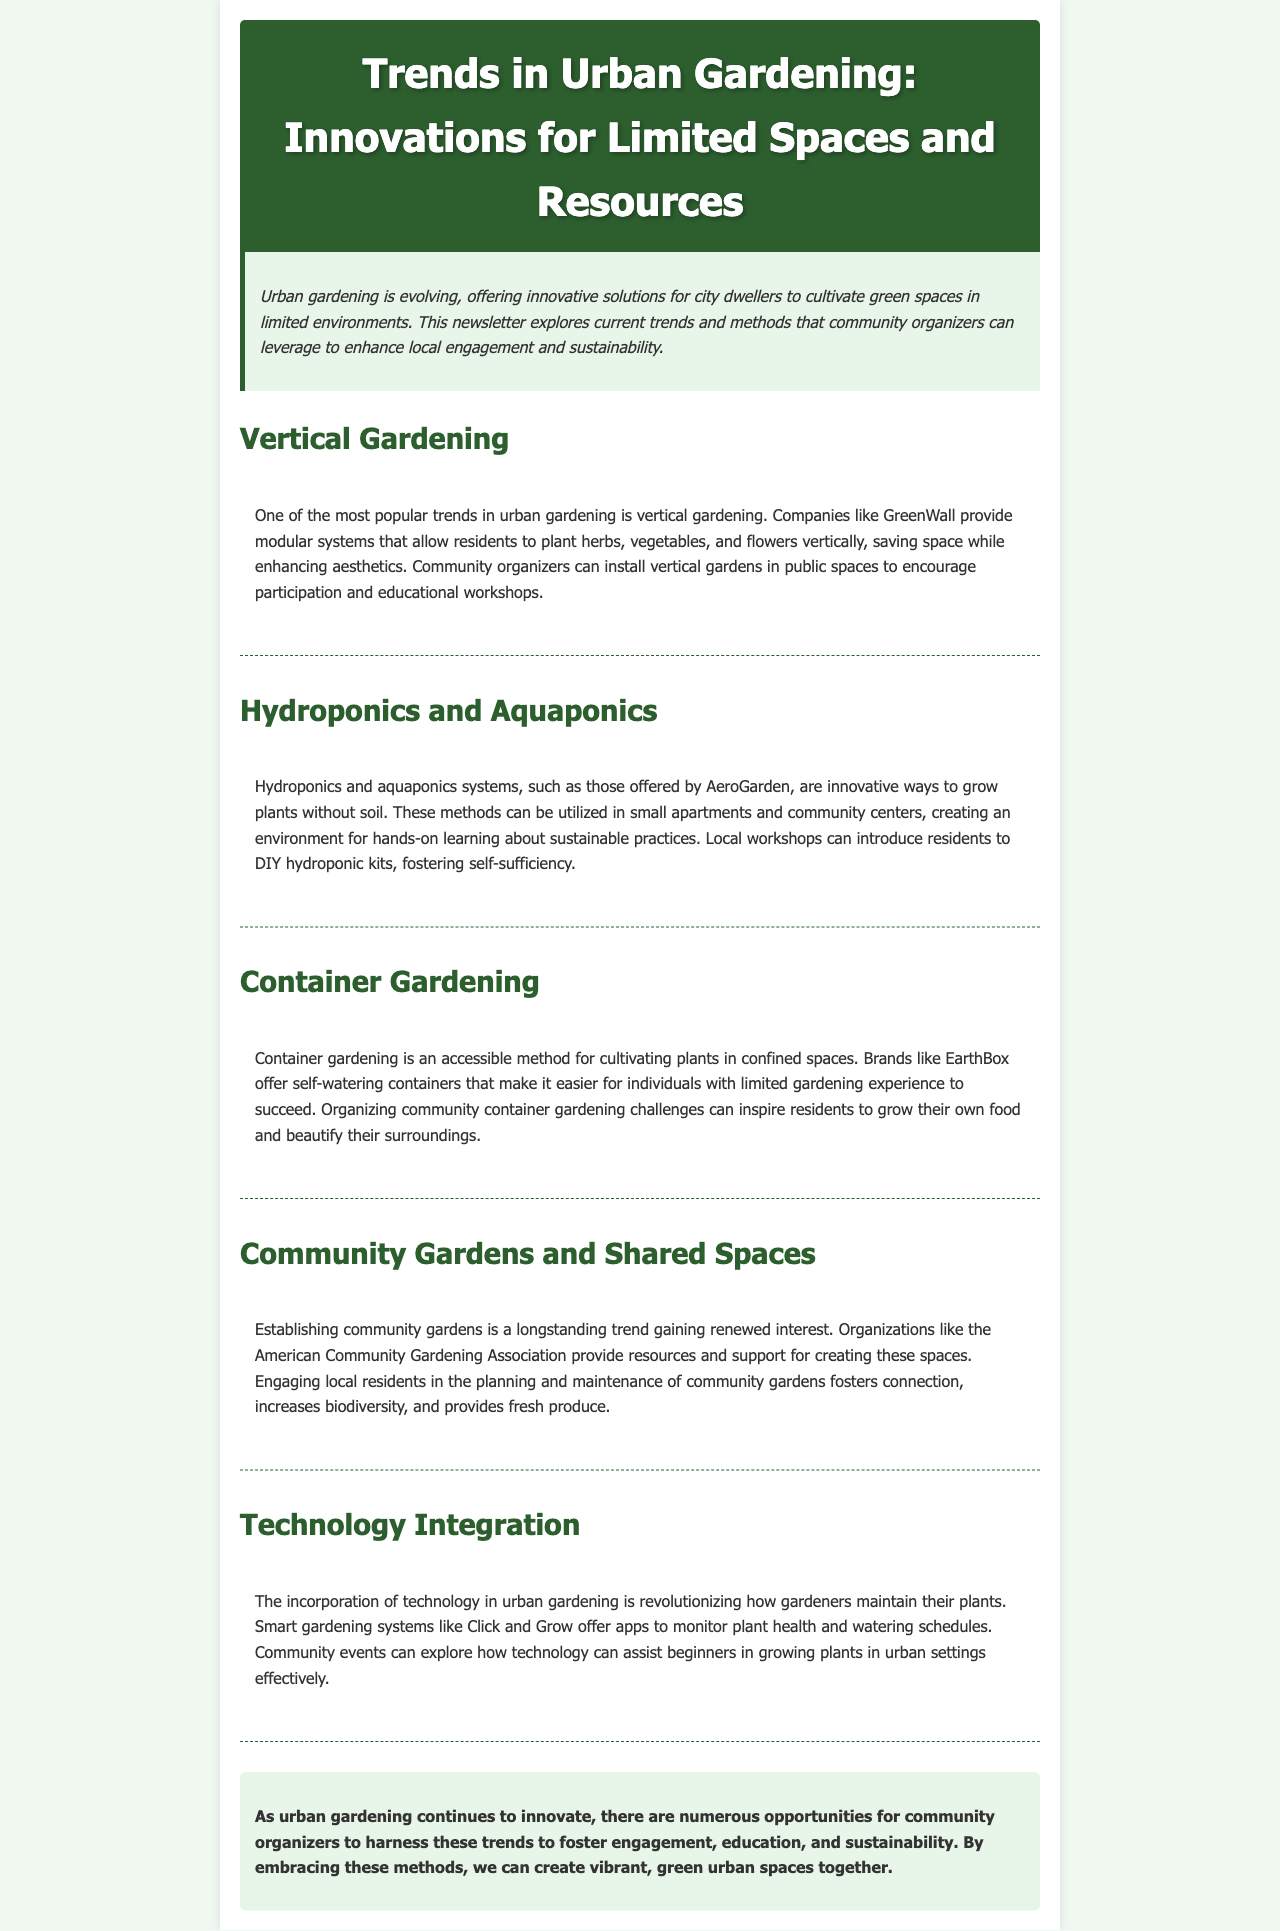What is one popular trend in urban gardening? The document states that one of the most popular trends in urban gardening is vertical gardening.
Answer: vertical gardening Which company provides modular systems for vertical gardening? The document mentions GreenWall as the company providing modular systems for vertical gardening.
Answer: GreenWall What two systems allow plant growth without soil? The text refers to hydroponics and aquaponics as the systems that allow plant growth without soil.
Answer: hydroponics and aquaponics What is a brand mentioned for container gardening? The document cites EarthBox as a brand that offers self-watering containers for container gardening.
Answer: EarthBox What organization supports the creation of community gardens? The American Community Gardening Association is mentioned as providing resources for creating community gardens.
Answer: American Community Gardening Association What technology assists in urban gardening monitoring? Click and Grow offers smart gardening systems that assist in monitoring plant health.
Answer: Click and Grow How can community organizers engage local residents in gardening? The document suggests organizing community container gardening challenges.
Answer: container gardening challenges What is the primary goal of embracing urban gardening trends according to the conclusion? The conclusion emphasizes fostering engagement, education, and sustainability as the primary goal.
Answer: engagement, education, and sustainability 